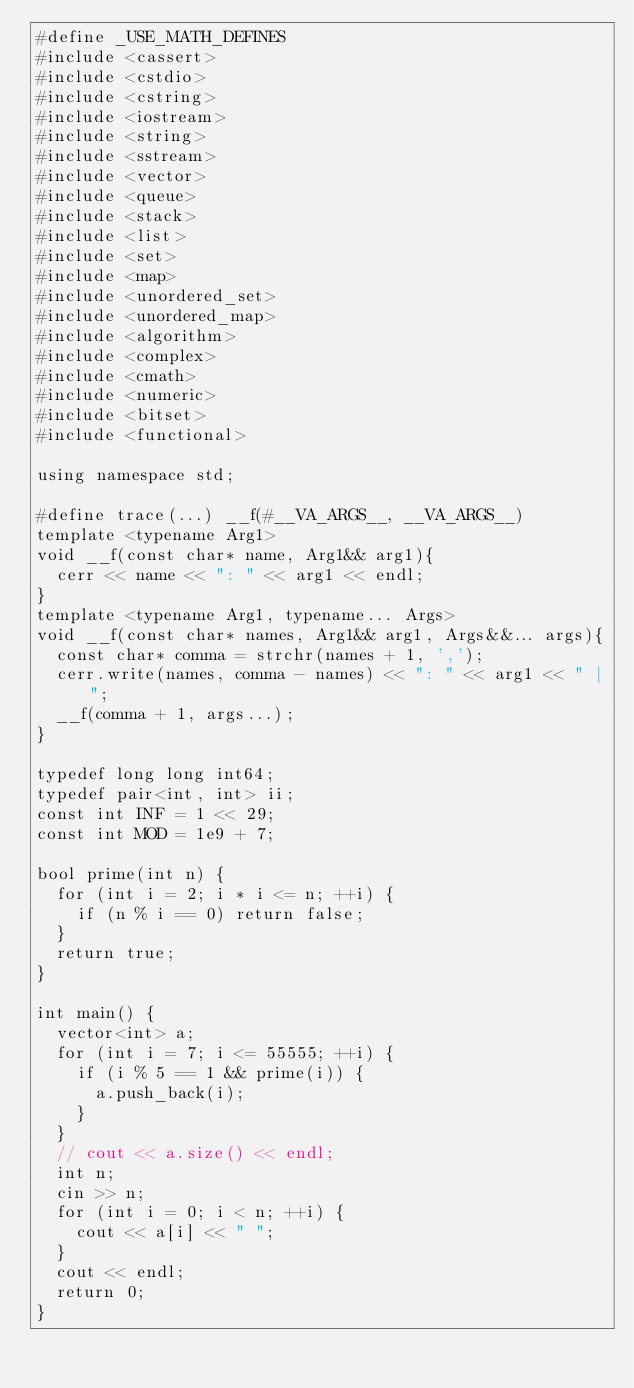<code> <loc_0><loc_0><loc_500><loc_500><_C++_>#define _USE_MATH_DEFINES
#include <cassert>
#include <cstdio>
#include <cstring>
#include <iostream>
#include <string>
#include <sstream>
#include <vector>
#include <queue>
#include <stack>
#include <list>
#include <set>
#include <map>
#include <unordered_set>
#include <unordered_map>
#include <algorithm>
#include <complex>
#include <cmath>
#include <numeric>
#include <bitset>
#include <functional>

using namespace std;

#define trace(...) __f(#__VA_ARGS__, __VA_ARGS__)
template <typename Arg1>
void __f(const char* name, Arg1&& arg1){
  cerr << name << ": " << arg1 << endl;
}
template <typename Arg1, typename... Args>
void __f(const char* names, Arg1&& arg1, Args&&... args){
  const char* comma = strchr(names + 1, ',');
  cerr.write(names, comma - names) << ": " << arg1 << " |";
  __f(comma + 1, args...);
}

typedef long long int64;
typedef pair<int, int> ii;
const int INF = 1 << 29;
const int MOD = 1e9 + 7;

bool prime(int n) {
  for (int i = 2; i * i <= n; ++i) {
    if (n % i == 0) return false;
  }
  return true;
}

int main() {
  vector<int> a;
  for (int i = 7; i <= 55555; ++i) {
    if (i % 5 == 1 && prime(i)) {
      a.push_back(i);
    }
  }
  // cout << a.size() << endl;
  int n;
  cin >> n;
  for (int i = 0; i < n; ++i) {
    cout << a[i] << " ";
  }
  cout << endl;
  return 0;
}
</code> 